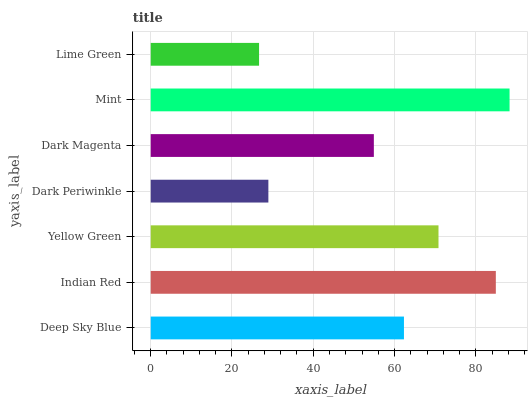Is Lime Green the minimum?
Answer yes or no. Yes. Is Mint the maximum?
Answer yes or no. Yes. Is Indian Red the minimum?
Answer yes or no. No. Is Indian Red the maximum?
Answer yes or no. No. Is Indian Red greater than Deep Sky Blue?
Answer yes or no. Yes. Is Deep Sky Blue less than Indian Red?
Answer yes or no. Yes. Is Deep Sky Blue greater than Indian Red?
Answer yes or no. No. Is Indian Red less than Deep Sky Blue?
Answer yes or no. No. Is Deep Sky Blue the high median?
Answer yes or no. Yes. Is Deep Sky Blue the low median?
Answer yes or no. Yes. Is Yellow Green the high median?
Answer yes or no. No. Is Dark Periwinkle the low median?
Answer yes or no. No. 